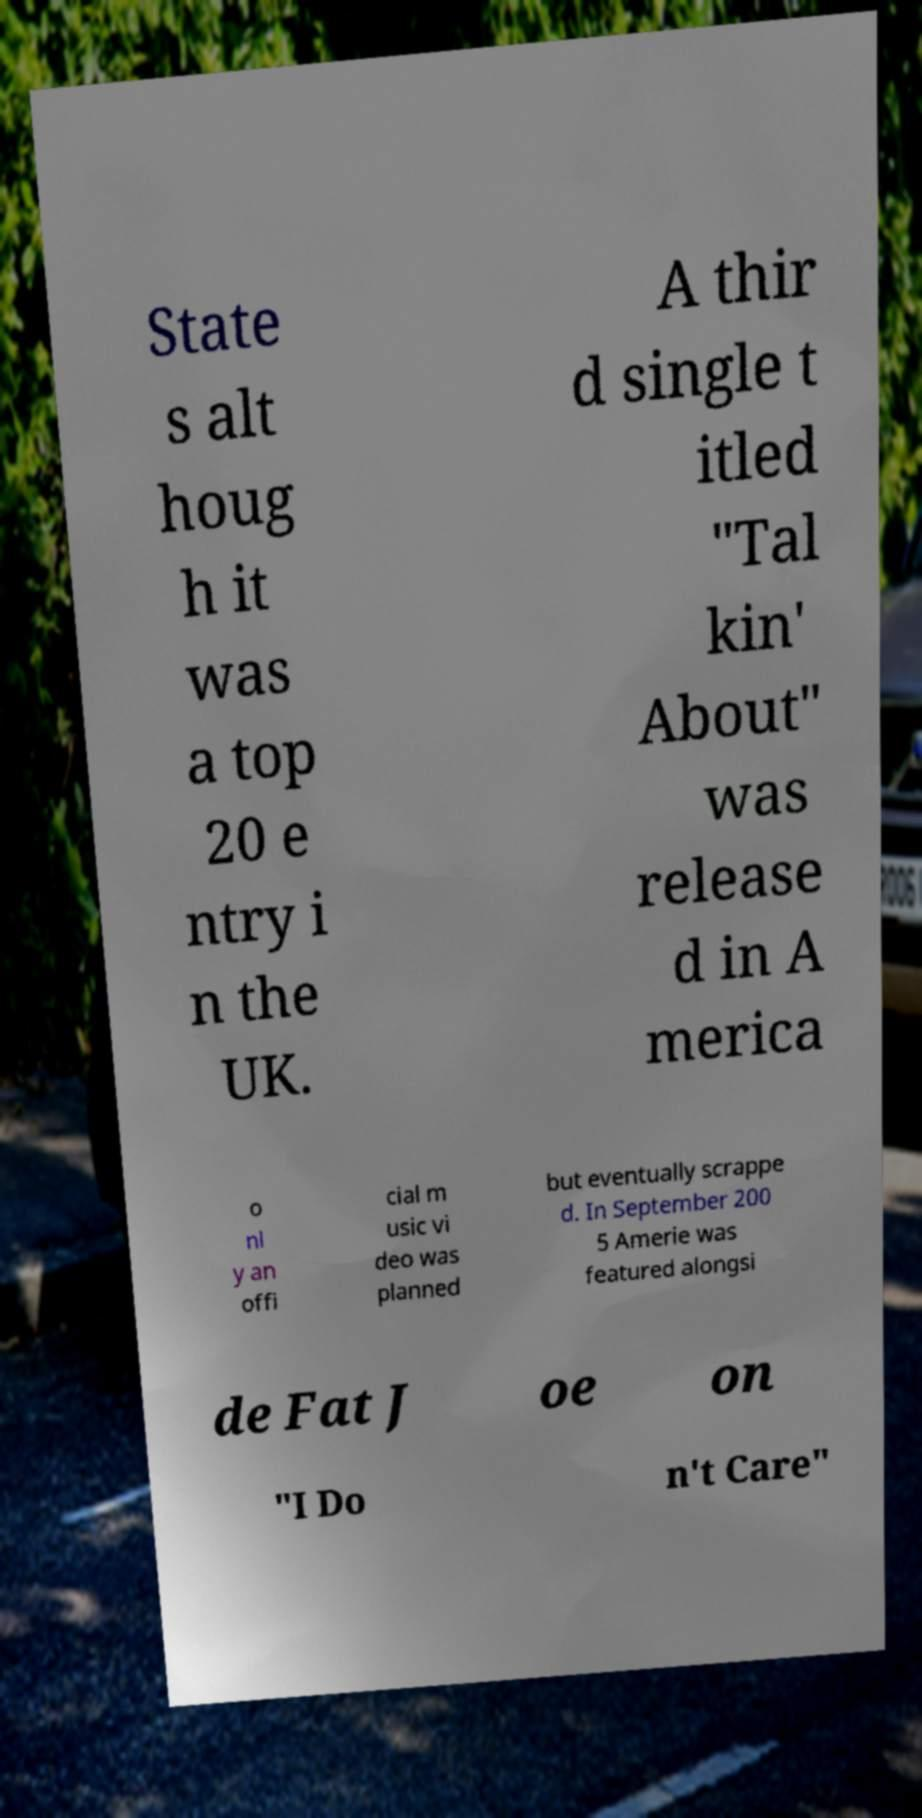Can you read and provide the text displayed in the image?This photo seems to have some interesting text. Can you extract and type it out for me? State s alt houg h it was a top 20 e ntry i n the UK. A thir d single t itled "Tal kin' About" was release d in A merica o nl y an offi cial m usic vi deo was planned but eventually scrappe d. In September 200 5 Amerie was featured alongsi de Fat J oe on "I Do n't Care" 